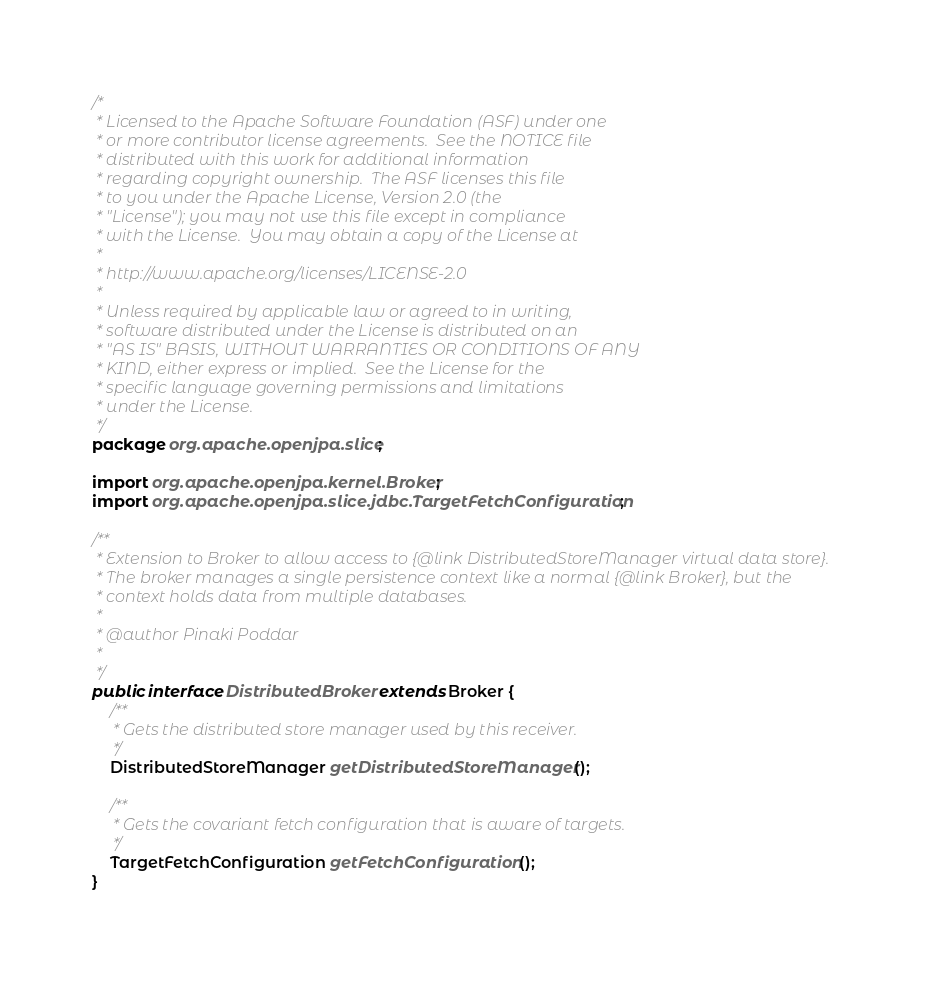Convert code to text. <code><loc_0><loc_0><loc_500><loc_500><_Java_>/*
 * Licensed to the Apache Software Foundation (ASF) under one
 * or more contributor license agreements.  See the NOTICE file
 * distributed with this work for additional information
 * regarding copyright ownership.  The ASF licenses this file
 * to you under the Apache License, Version 2.0 (the
 * "License"); you may not use this file except in compliance
 * with the License.  You may obtain a copy of the License at
 *
 * http://www.apache.org/licenses/LICENSE-2.0
 *
 * Unless required by applicable law or agreed to in writing,
 * software distributed under the License is distributed on an
 * "AS IS" BASIS, WITHOUT WARRANTIES OR CONDITIONS OF ANY
 * KIND, either express or implied.  See the License for the
 * specific language governing permissions and limitations
 * under the License.    
 */
package org.apache.openjpa.slice;

import org.apache.openjpa.kernel.Broker;
import org.apache.openjpa.slice.jdbc.TargetFetchConfiguration;

/**
 * Extension to Broker to allow access to {@link DistributedStoreManager virtual data store}.
 * The broker manages a single persistence context like a normal {@link Broker}, but the
 * context holds data from multiple databases. 
 * 
 * @author Pinaki Poddar
 *
 */
public interface DistributedBroker extends Broker {
    /**
     * Gets the distributed store manager used by this receiver.
     */
    DistributedStoreManager getDistributedStoreManager();
   
    /**
     * Gets the covariant fetch configuration that is aware of targets.
     */
    TargetFetchConfiguration getFetchConfiguration();
}
</code> 